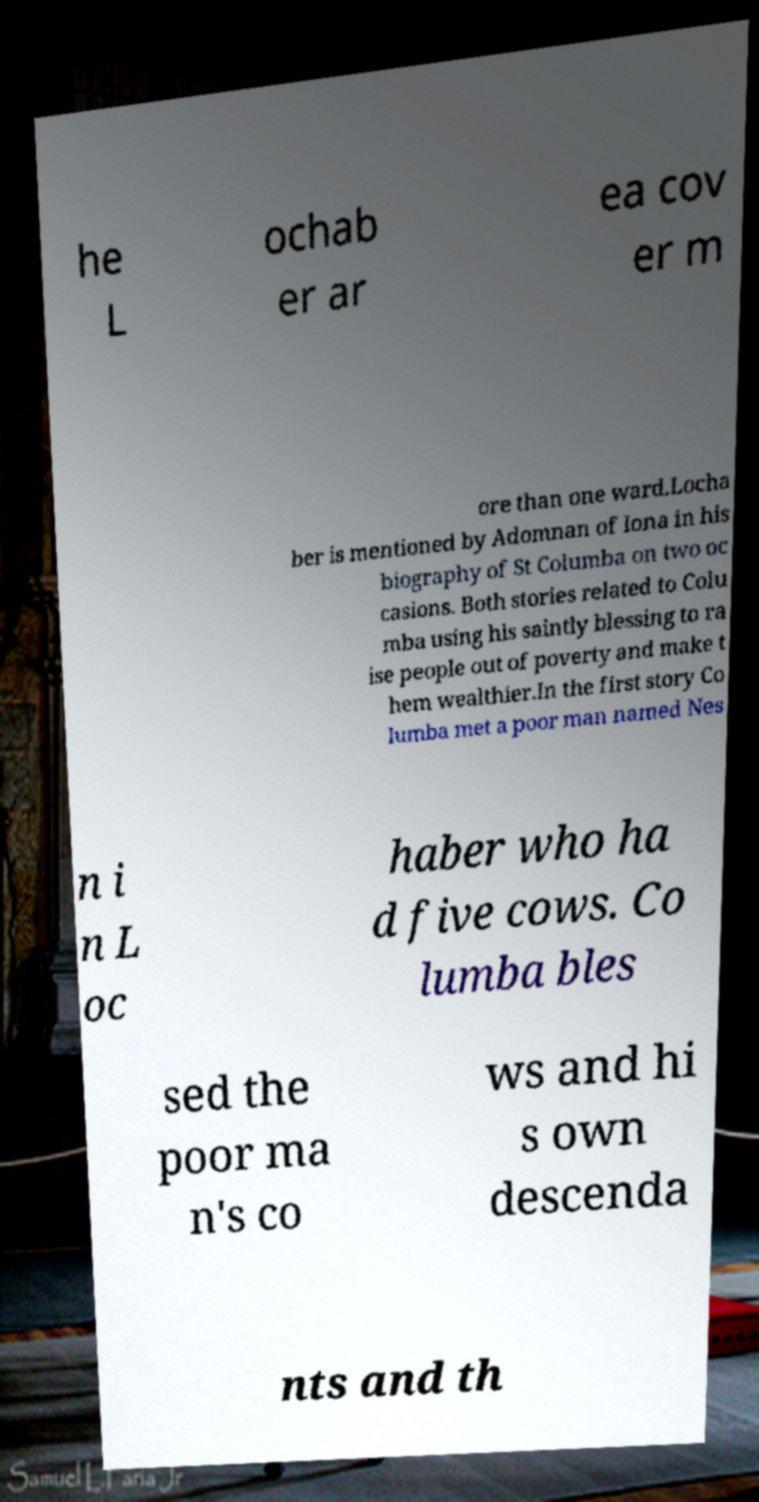There's text embedded in this image that I need extracted. Can you transcribe it verbatim? he L ochab er ar ea cov er m ore than one ward.Locha ber is mentioned by Adomnan of Iona in his biography of St Columba on two oc casions. Both stories related to Colu mba using his saintly blessing to ra ise people out of poverty and make t hem wealthier.In the first story Co lumba met a poor man named Nes n i n L oc haber who ha d five cows. Co lumba bles sed the poor ma n's co ws and hi s own descenda nts and th 